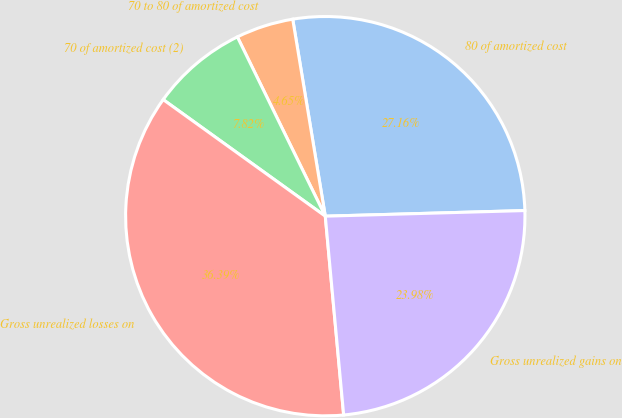Convert chart to OTSL. <chart><loc_0><loc_0><loc_500><loc_500><pie_chart><fcel>80 of amortized cost<fcel>70 to 80 of amortized cost<fcel>70 of amortized cost (2)<fcel>Gross unrealized losses on<fcel>Gross unrealized gains on<nl><fcel>27.16%<fcel>4.65%<fcel>7.82%<fcel>36.39%<fcel>23.98%<nl></chart> 